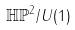Convert formula to latex. <formula><loc_0><loc_0><loc_500><loc_500>\mathbb { H P } ^ { 2 } / U ( 1 )</formula> 